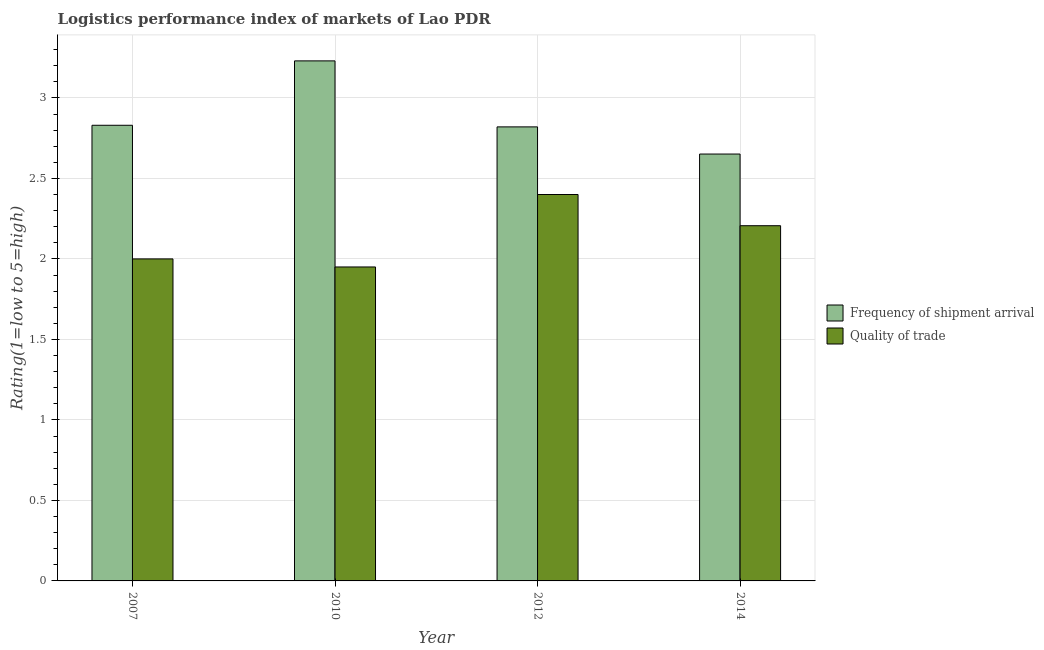How many groups of bars are there?
Offer a terse response. 4. Across all years, what is the maximum lpi of frequency of shipment arrival?
Give a very brief answer. 3.23. Across all years, what is the minimum lpi of frequency of shipment arrival?
Offer a terse response. 2.65. In which year was the lpi quality of trade maximum?
Your answer should be compact. 2012. What is the total lpi of frequency of shipment arrival in the graph?
Keep it short and to the point. 11.53. What is the difference between the lpi of frequency of shipment arrival in 2012 and that in 2014?
Offer a terse response. 0.17. What is the difference between the lpi of frequency of shipment arrival in 2010 and the lpi quality of trade in 2014?
Your response must be concise. 0.58. What is the average lpi of frequency of shipment arrival per year?
Provide a short and direct response. 2.88. In how many years, is the lpi quality of trade greater than 0.9?
Your answer should be very brief. 4. What is the ratio of the lpi of frequency of shipment arrival in 2010 to that in 2012?
Your answer should be very brief. 1.15. Is the lpi of frequency of shipment arrival in 2007 less than that in 2014?
Provide a succinct answer. No. What is the difference between the highest and the second highest lpi quality of trade?
Keep it short and to the point. 0.19. What is the difference between the highest and the lowest lpi quality of trade?
Provide a short and direct response. 0.45. In how many years, is the lpi quality of trade greater than the average lpi quality of trade taken over all years?
Make the answer very short. 2. What does the 2nd bar from the left in 2012 represents?
Provide a short and direct response. Quality of trade. What does the 1st bar from the right in 2010 represents?
Your answer should be very brief. Quality of trade. How many bars are there?
Ensure brevity in your answer.  8. What is the difference between two consecutive major ticks on the Y-axis?
Make the answer very short. 0.5. Does the graph contain any zero values?
Your answer should be very brief. No. Where does the legend appear in the graph?
Offer a very short reply. Center right. What is the title of the graph?
Your response must be concise. Logistics performance index of markets of Lao PDR. Does "Non-residents" appear as one of the legend labels in the graph?
Your response must be concise. No. What is the label or title of the Y-axis?
Provide a succinct answer. Rating(1=low to 5=high). What is the Rating(1=low to 5=high) in Frequency of shipment arrival in 2007?
Your response must be concise. 2.83. What is the Rating(1=low to 5=high) in Quality of trade in 2007?
Ensure brevity in your answer.  2. What is the Rating(1=low to 5=high) in Frequency of shipment arrival in 2010?
Your response must be concise. 3.23. What is the Rating(1=low to 5=high) of Quality of trade in 2010?
Make the answer very short. 1.95. What is the Rating(1=low to 5=high) in Frequency of shipment arrival in 2012?
Keep it short and to the point. 2.82. What is the Rating(1=low to 5=high) in Frequency of shipment arrival in 2014?
Keep it short and to the point. 2.65. What is the Rating(1=low to 5=high) in Quality of trade in 2014?
Provide a succinct answer. 2.21. Across all years, what is the maximum Rating(1=low to 5=high) of Frequency of shipment arrival?
Ensure brevity in your answer.  3.23. Across all years, what is the maximum Rating(1=low to 5=high) of Quality of trade?
Give a very brief answer. 2.4. Across all years, what is the minimum Rating(1=low to 5=high) in Frequency of shipment arrival?
Your answer should be compact. 2.65. Across all years, what is the minimum Rating(1=low to 5=high) of Quality of trade?
Give a very brief answer. 1.95. What is the total Rating(1=low to 5=high) in Frequency of shipment arrival in the graph?
Your response must be concise. 11.53. What is the total Rating(1=low to 5=high) in Quality of trade in the graph?
Make the answer very short. 8.56. What is the difference between the Rating(1=low to 5=high) in Quality of trade in 2007 and that in 2010?
Keep it short and to the point. 0.05. What is the difference between the Rating(1=low to 5=high) in Quality of trade in 2007 and that in 2012?
Offer a very short reply. -0.4. What is the difference between the Rating(1=low to 5=high) of Frequency of shipment arrival in 2007 and that in 2014?
Make the answer very short. 0.18. What is the difference between the Rating(1=low to 5=high) of Quality of trade in 2007 and that in 2014?
Provide a succinct answer. -0.21. What is the difference between the Rating(1=low to 5=high) in Frequency of shipment arrival in 2010 and that in 2012?
Your answer should be very brief. 0.41. What is the difference between the Rating(1=low to 5=high) in Quality of trade in 2010 and that in 2012?
Your answer should be compact. -0.45. What is the difference between the Rating(1=low to 5=high) in Frequency of shipment arrival in 2010 and that in 2014?
Offer a very short reply. 0.58. What is the difference between the Rating(1=low to 5=high) of Quality of trade in 2010 and that in 2014?
Your response must be concise. -0.26. What is the difference between the Rating(1=low to 5=high) of Frequency of shipment arrival in 2012 and that in 2014?
Your answer should be compact. 0.17. What is the difference between the Rating(1=low to 5=high) of Quality of trade in 2012 and that in 2014?
Provide a succinct answer. 0.19. What is the difference between the Rating(1=low to 5=high) of Frequency of shipment arrival in 2007 and the Rating(1=low to 5=high) of Quality of trade in 2012?
Your answer should be very brief. 0.43. What is the difference between the Rating(1=low to 5=high) in Frequency of shipment arrival in 2007 and the Rating(1=low to 5=high) in Quality of trade in 2014?
Your answer should be very brief. 0.62. What is the difference between the Rating(1=low to 5=high) of Frequency of shipment arrival in 2010 and the Rating(1=low to 5=high) of Quality of trade in 2012?
Provide a succinct answer. 0.83. What is the difference between the Rating(1=low to 5=high) in Frequency of shipment arrival in 2010 and the Rating(1=low to 5=high) in Quality of trade in 2014?
Offer a terse response. 1.02. What is the difference between the Rating(1=low to 5=high) of Frequency of shipment arrival in 2012 and the Rating(1=low to 5=high) of Quality of trade in 2014?
Offer a very short reply. 0.61. What is the average Rating(1=low to 5=high) in Frequency of shipment arrival per year?
Keep it short and to the point. 2.88. What is the average Rating(1=low to 5=high) of Quality of trade per year?
Make the answer very short. 2.14. In the year 2007, what is the difference between the Rating(1=low to 5=high) in Frequency of shipment arrival and Rating(1=low to 5=high) in Quality of trade?
Give a very brief answer. 0.83. In the year 2010, what is the difference between the Rating(1=low to 5=high) in Frequency of shipment arrival and Rating(1=low to 5=high) in Quality of trade?
Offer a terse response. 1.28. In the year 2012, what is the difference between the Rating(1=low to 5=high) of Frequency of shipment arrival and Rating(1=low to 5=high) of Quality of trade?
Your response must be concise. 0.42. In the year 2014, what is the difference between the Rating(1=low to 5=high) of Frequency of shipment arrival and Rating(1=low to 5=high) of Quality of trade?
Your response must be concise. 0.45. What is the ratio of the Rating(1=low to 5=high) of Frequency of shipment arrival in 2007 to that in 2010?
Provide a succinct answer. 0.88. What is the ratio of the Rating(1=low to 5=high) in Quality of trade in 2007 to that in 2010?
Offer a very short reply. 1.03. What is the ratio of the Rating(1=low to 5=high) in Frequency of shipment arrival in 2007 to that in 2014?
Keep it short and to the point. 1.07. What is the ratio of the Rating(1=low to 5=high) of Quality of trade in 2007 to that in 2014?
Your response must be concise. 0.91. What is the ratio of the Rating(1=low to 5=high) in Frequency of shipment arrival in 2010 to that in 2012?
Offer a terse response. 1.15. What is the ratio of the Rating(1=low to 5=high) in Quality of trade in 2010 to that in 2012?
Provide a succinct answer. 0.81. What is the ratio of the Rating(1=low to 5=high) in Frequency of shipment arrival in 2010 to that in 2014?
Make the answer very short. 1.22. What is the ratio of the Rating(1=low to 5=high) in Quality of trade in 2010 to that in 2014?
Offer a very short reply. 0.88. What is the ratio of the Rating(1=low to 5=high) in Frequency of shipment arrival in 2012 to that in 2014?
Offer a terse response. 1.06. What is the ratio of the Rating(1=low to 5=high) in Quality of trade in 2012 to that in 2014?
Offer a very short reply. 1.09. What is the difference between the highest and the second highest Rating(1=low to 5=high) of Quality of trade?
Make the answer very short. 0.19. What is the difference between the highest and the lowest Rating(1=low to 5=high) of Frequency of shipment arrival?
Give a very brief answer. 0.58. What is the difference between the highest and the lowest Rating(1=low to 5=high) of Quality of trade?
Your answer should be very brief. 0.45. 